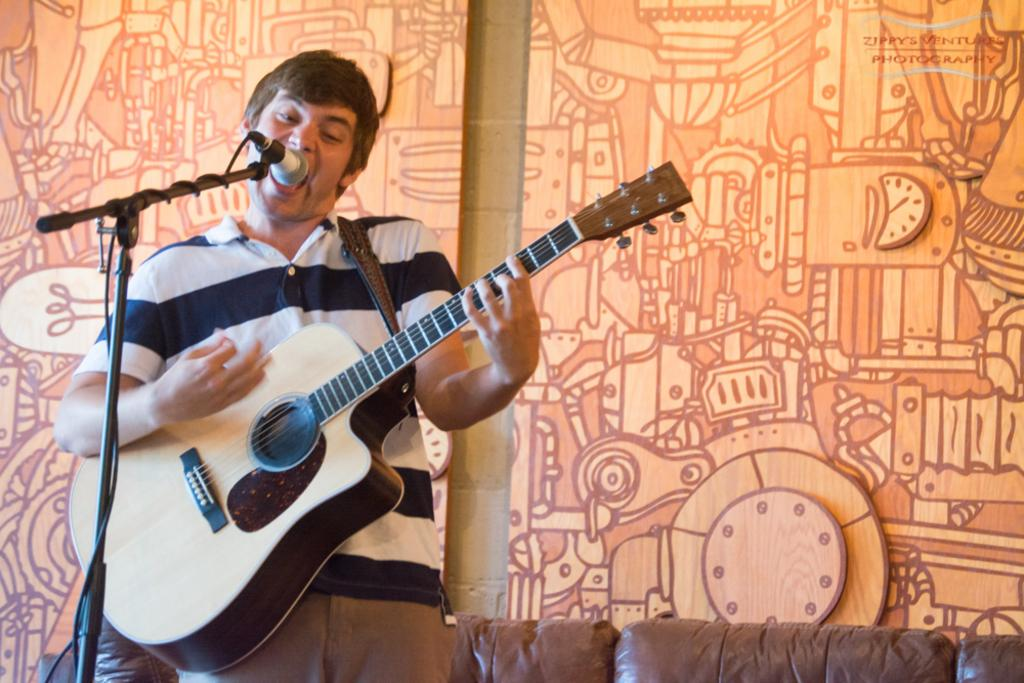What is the person in the image doing? The person is playing a guitar and singing. What is in front of the person to help with the singing? There is a microphone in front of the person. What is the microphone attached to? The microphone is attached to a mic stand. What can be seen on the walls in the background? There are paintings on the wall in the background. What type of furniture is present in the room? There are sofas in the room. What type of breakfast is being prepared in the image? There is no mention of breakfast in the image. 